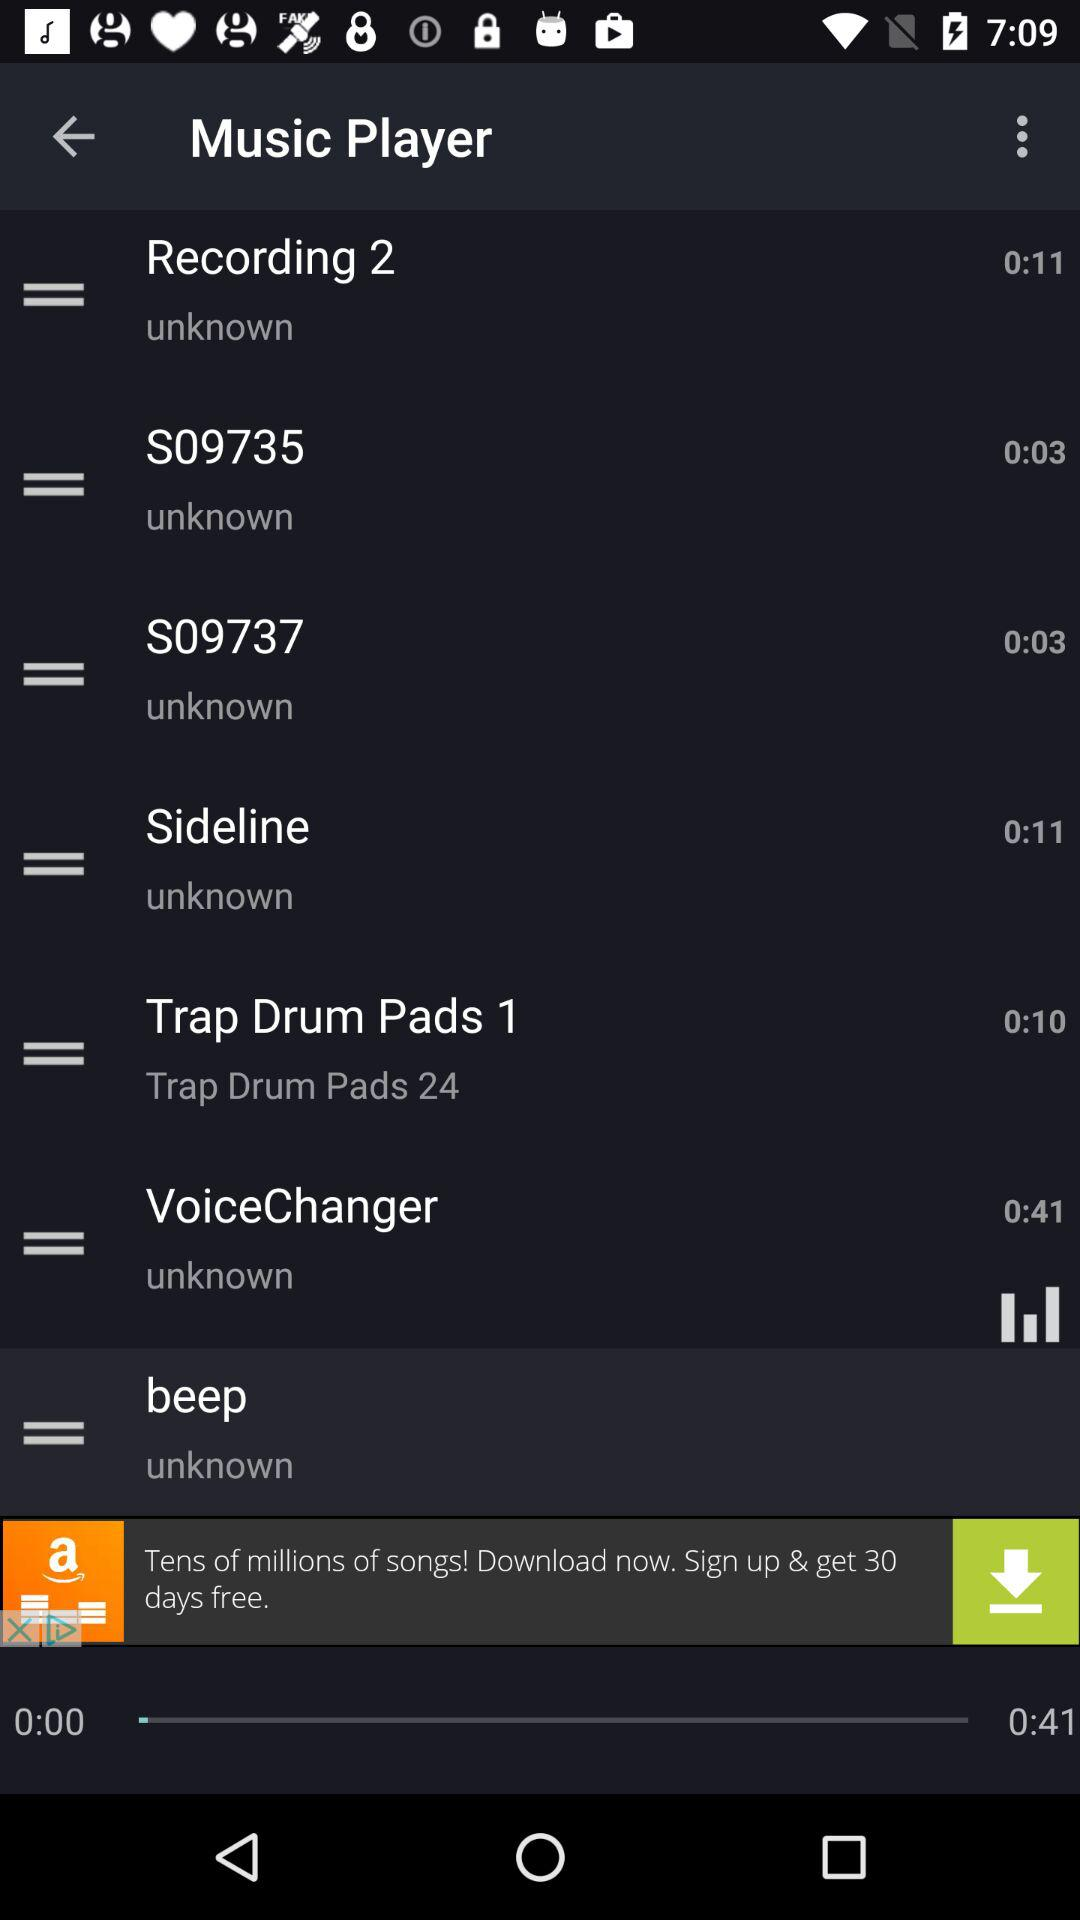What is the duration of the "Recording 2" audio? The duration is 11 seconds. 